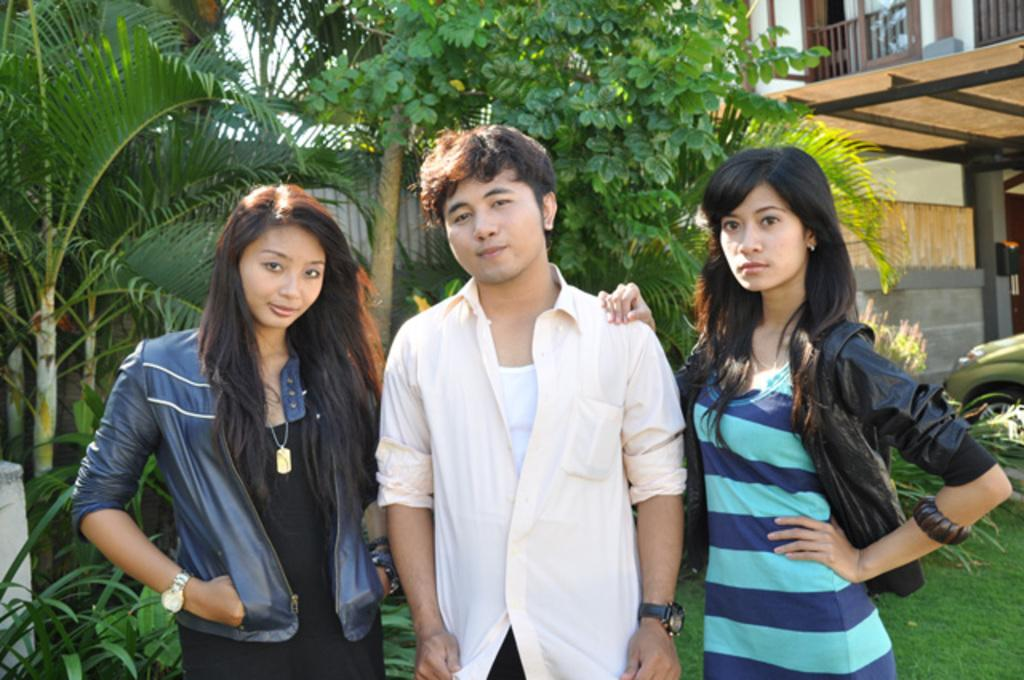How many people are in the image? There are three people in the image: a man and two women. What is the man doing in relation to the two women? The man is standing between the two women. What is the group doing in the image? The group is posing for the camera. What can be seen in the background of the image? There are trees and a building visible in the background of the image. What type of friction can be seen between the man and the women in the image? There is no friction visible between the man and the women in the image; they are posing together for a photo. What kind of attraction is present in the image? There is no attraction mentioned or depicted in the image; it simply shows a group of people posing for a photo. 